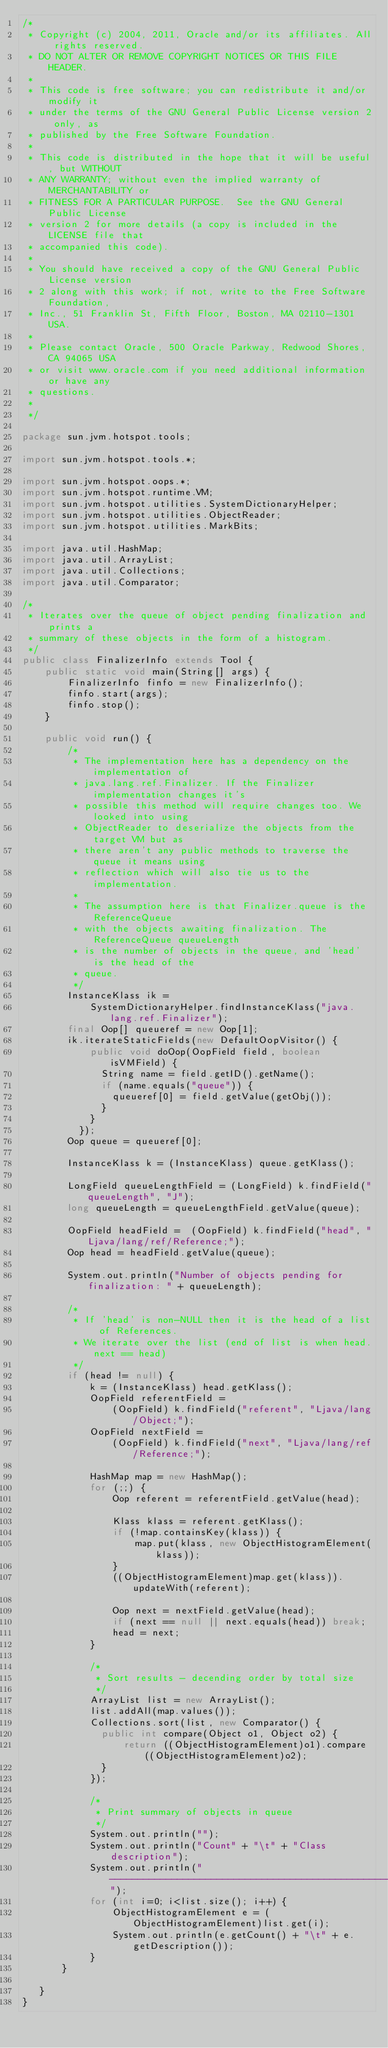Convert code to text. <code><loc_0><loc_0><loc_500><loc_500><_Java_>/*
 * Copyright (c) 2004, 2011, Oracle and/or its affiliates. All rights reserved.
 * DO NOT ALTER OR REMOVE COPYRIGHT NOTICES OR THIS FILE HEADER.
 *
 * This code is free software; you can redistribute it and/or modify it
 * under the terms of the GNU General Public License version 2 only, as
 * published by the Free Software Foundation.
 *
 * This code is distributed in the hope that it will be useful, but WITHOUT
 * ANY WARRANTY; without even the implied warranty of MERCHANTABILITY or
 * FITNESS FOR A PARTICULAR PURPOSE.  See the GNU General Public License
 * version 2 for more details (a copy is included in the LICENSE file that
 * accompanied this code).
 *
 * You should have received a copy of the GNU General Public License version
 * 2 along with this work; if not, write to the Free Software Foundation,
 * Inc., 51 Franklin St, Fifth Floor, Boston, MA 02110-1301 USA.
 *
 * Please contact Oracle, 500 Oracle Parkway, Redwood Shores, CA 94065 USA
 * or visit www.oracle.com if you need additional information or have any
 * questions.
 *
 */

package sun.jvm.hotspot.tools;

import sun.jvm.hotspot.tools.*;

import sun.jvm.hotspot.oops.*;
import sun.jvm.hotspot.runtime.VM;
import sun.jvm.hotspot.utilities.SystemDictionaryHelper;
import sun.jvm.hotspot.utilities.ObjectReader;
import sun.jvm.hotspot.utilities.MarkBits;

import java.util.HashMap;
import java.util.ArrayList;
import java.util.Collections;
import java.util.Comparator;

/*
 * Iterates over the queue of object pending finalization and prints a
 * summary of these objects in the form of a histogram.
 */
public class FinalizerInfo extends Tool {
    public static void main(String[] args) {
        FinalizerInfo finfo = new FinalizerInfo();
        finfo.start(args);
        finfo.stop();
    }

    public void run() {
        /*
         * The implementation here has a dependency on the implementation of
         * java.lang.ref.Finalizer. If the Finalizer implementation changes it's
         * possible this method will require changes too. We looked into using
         * ObjectReader to deserialize the objects from the target VM but as
         * there aren't any public methods to traverse the queue it means using
         * reflection which will also tie us to the implementation.
         *
         * The assumption here is that Finalizer.queue is the ReferenceQueue
         * with the objects awaiting finalization. The ReferenceQueue queueLength
         * is the number of objects in the queue, and 'head' is the head of the
         * queue.
         */
        InstanceKlass ik =
            SystemDictionaryHelper.findInstanceKlass("java.lang.ref.Finalizer");
        final Oop[] queueref = new Oop[1];
        ik.iterateStaticFields(new DefaultOopVisitor() {
            public void doOop(OopField field, boolean isVMField) {
              String name = field.getID().getName();
              if (name.equals("queue")) {
                queueref[0] = field.getValue(getObj());
              }
            }
          });
        Oop queue = queueref[0];

        InstanceKlass k = (InstanceKlass) queue.getKlass();

        LongField queueLengthField = (LongField) k.findField("queueLength", "J");
        long queueLength = queueLengthField.getValue(queue);

        OopField headField =  (OopField) k.findField("head", "Ljava/lang/ref/Reference;");
        Oop head = headField.getValue(queue);

        System.out.println("Number of objects pending for finalization: " + queueLength);

        /*
         * If 'head' is non-NULL then it is the head of a list of References.
         * We iterate over the list (end of list is when head.next == head)
         */
        if (head != null) {
            k = (InstanceKlass) head.getKlass();
            OopField referentField =
                (OopField) k.findField("referent", "Ljava/lang/Object;");
            OopField nextField =
                (OopField) k.findField("next", "Ljava/lang/ref/Reference;");

            HashMap map = new HashMap();
            for (;;) {
                Oop referent = referentField.getValue(head);

                Klass klass = referent.getKlass();
                if (!map.containsKey(klass)) {
                    map.put(klass, new ObjectHistogramElement(klass));
                }
                ((ObjectHistogramElement)map.get(klass)).updateWith(referent);

                Oop next = nextField.getValue(head);
                if (next == null || next.equals(head)) break;
                head = next;
            }

            /*
             * Sort results - decending order by total size
             */
            ArrayList list = new ArrayList();
            list.addAll(map.values());
            Collections.sort(list, new Comparator() {
              public int compare(Object o1, Object o2) {
                  return ((ObjectHistogramElement)o1).compare((ObjectHistogramElement)o2);
              }
            });

            /*
             * Print summary of objects in queue
             */
            System.out.println("");
            System.out.println("Count" + "\t" + "Class description");
            System.out.println("-------------------------------------------------------");
            for (int i=0; i<list.size(); i++) {
                ObjectHistogramElement e = (ObjectHistogramElement)list.get(i);
                System.out.println(e.getCount() + "\t" + e.getDescription());
            }
       }

   }
}
</code> 